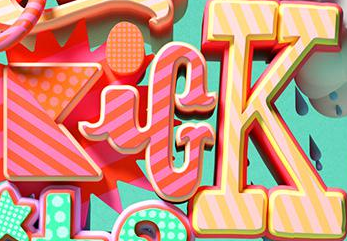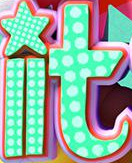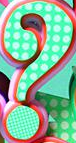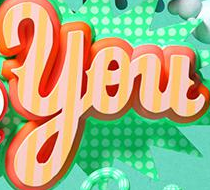Read the text content from these images in order, separated by a semicolon. KicK; it; ?; You 